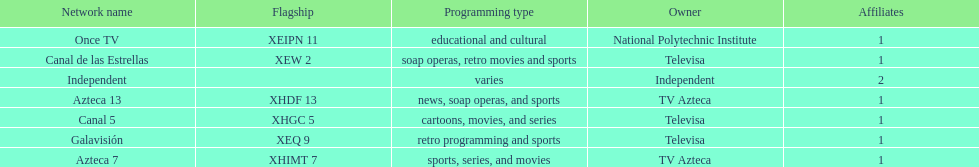How many networks do not air sports? 2. 